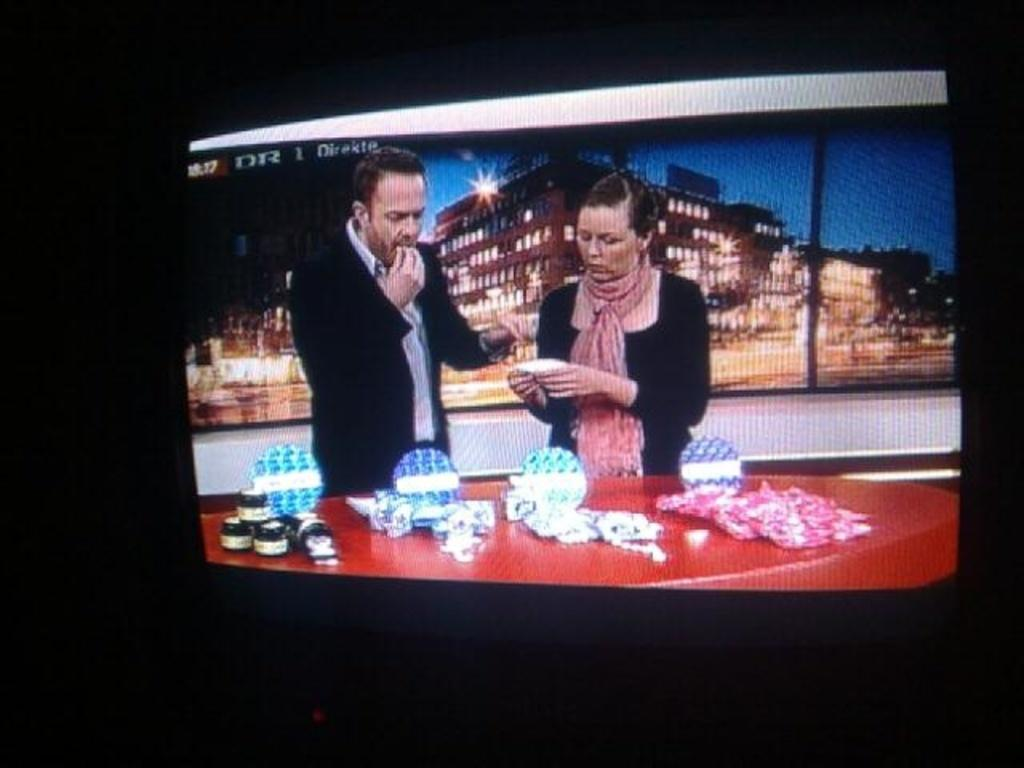<image>
Describe the image concisely. Two people are seen on a monitor, which is labelled "DR 1 Direkte" 